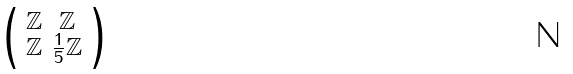<formula> <loc_0><loc_0><loc_500><loc_500>\begin{psmallmatrix} \mathbb { Z } & \mathbb { Z } \\ \mathbb { Z } & \frac { 1 } { 5 } \mathbb { Z } \end{psmallmatrix}</formula> 